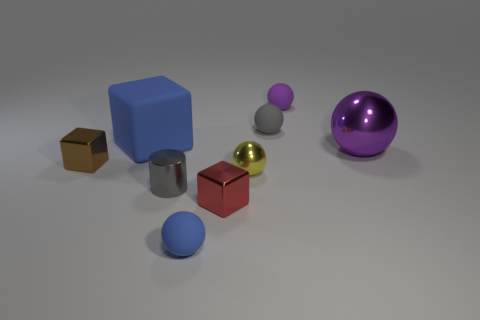How many other things are the same color as the small metallic ball?
Provide a succinct answer. 0. Is the number of small gray metal cylinders that are behind the large metallic thing greater than the number of big spheres?
Ensure brevity in your answer.  No. Is the material of the small blue ball the same as the large ball?
Your answer should be compact. No. How many objects are small things left of the rubber cube or small red metal cubes?
Give a very brief answer. 2. What number of other objects are there of the same size as the cylinder?
Provide a short and direct response. 6. Is the number of small things behind the brown metallic thing the same as the number of small cylinders that are in front of the red shiny thing?
Your response must be concise. No. What color is the tiny metal thing that is the same shape as the big shiny object?
Make the answer very short. Yellow. Are there any other things that have the same shape as the yellow object?
Your response must be concise. Yes. Does the cube right of the blue matte cube have the same color as the tiny cylinder?
Your answer should be very brief. No. The blue matte thing that is the same shape as the small purple matte thing is what size?
Your answer should be very brief. Small. 